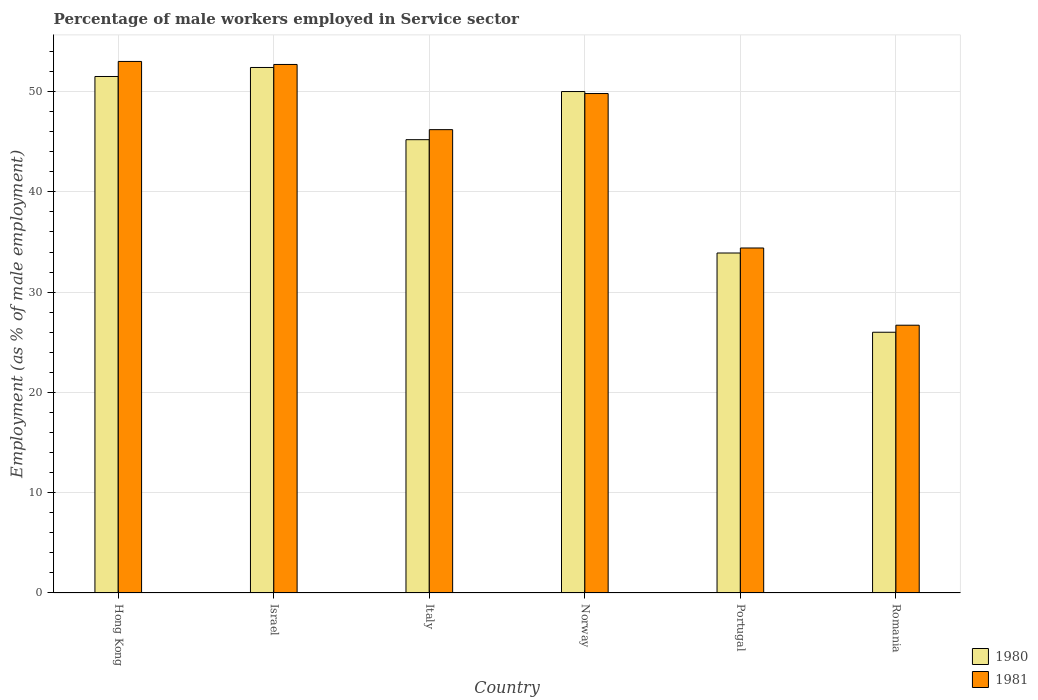How many different coloured bars are there?
Provide a short and direct response. 2. How many groups of bars are there?
Your response must be concise. 6. Are the number of bars per tick equal to the number of legend labels?
Ensure brevity in your answer.  Yes. How many bars are there on the 4th tick from the left?
Keep it short and to the point. 2. What is the label of the 1st group of bars from the left?
Your answer should be very brief. Hong Kong. Across all countries, what is the maximum percentage of male workers employed in Service sector in 1980?
Offer a very short reply. 52.4. Across all countries, what is the minimum percentage of male workers employed in Service sector in 1980?
Keep it short and to the point. 26. In which country was the percentage of male workers employed in Service sector in 1981 maximum?
Your answer should be compact. Hong Kong. In which country was the percentage of male workers employed in Service sector in 1980 minimum?
Keep it short and to the point. Romania. What is the total percentage of male workers employed in Service sector in 1980 in the graph?
Keep it short and to the point. 259. What is the difference between the percentage of male workers employed in Service sector in 1981 in Israel and that in Italy?
Keep it short and to the point. 6.5. What is the difference between the percentage of male workers employed in Service sector in 1981 in Hong Kong and the percentage of male workers employed in Service sector in 1980 in Italy?
Make the answer very short. 7.8. What is the average percentage of male workers employed in Service sector in 1980 per country?
Ensure brevity in your answer.  43.17. What is the difference between the percentage of male workers employed in Service sector of/in 1981 and percentage of male workers employed in Service sector of/in 1980 in Italy?
Make the answer very short. 1. In how many countries, is the percentage of male workers employed in Service sector in 1981 greater than 32 %?
Your answer should be compact. 5. What is the ratio of the percentage of male workers employed in Service sector in 1981 in Hong Kong to that in Portugal?
Provide a succinct answer. 1.54. Is the percentage of male workers employed in Service sector in 1981 in Norway less than that in Romania?
Your answer should be compact. No. Is the difference between the percentage of male workers employed in Service sector in 1981 in Norway and Portugal greater than the difference between the percentage of male workers employed in Service sector in 1980 in Norway and Portugal?
Give a very brief answer. No. What is the difference between the highest and the second highest percentage of male workers employed in Service sector in 1981?
Offer a terse response. -2.9. What is the difference between the highest and the lowest percentage of male workers employed in Service sector in 1980?
Your answer should be compact. 26.4. Is the sum of the percentage of male workers employed in Service sector in 1980 in Israel and Italy greater than the maximum percentage of male workers employed in Service sector in 1981 across all countries?
Offer a terse response. Yes. What does the 1st bar from the left in Norway represents?
Give a very brief answer. 1980. Are all the bars in the graph horizontal?
Your answer should be very brief. No. How many countries are there in the graph?
Offer a very short reply. 6. What is the difference between two consecutive major ticks on the Y-axis?
Make the answer very short. 10. Are the values on the major ticks of Y-axis written in scientific E-notation?
Give a very brief answer. No. Does the graph contain grids?
Make the answer very short. Yes. What is the title of the graph?
Provide a short and direct response. Percentage of male workers employed in Service sector. What is the label or title of the Y-axis?
Your answer should be very brief. Employment (as % of male employment). What is the Employment (as % of male employment) in 1980 in Hong Kong?
Keep it short and to the point. 51.5. What is the Employment (as % of male employment) of 1980 in Israel?
Provide a succinct answer. 52.4. What is the Employment (as % of male employment) in 1981 in Israel?
Keep it short and to the point. 52.7. What is the Employment (as % of male employment) of 1980 in Italy?
Offer a terse response. 45.2. What is the Employment (as % of male employment) of 1981 in Italy?
Offer a very short reply. 46.2. What is the Employment (as % of male employment) of 1981 in Norway?
Your answer should be compact. 49.8. What is the Employment (as % of male employment) in 1980 in Portugal?
Make the answer very short. 33.9. What is the Employment (as % of male employment) of 1981 in Portugal?
Your answer should be very brief. 34.4. What is the Employment (as % of male employment) of 1980 in Romania?
Offer a terse response. 26. What is the Employment (as % of male employment) of 1981 in Romania?
Ensure brevity in your answer.  26.7. Across all countries, what is the maximum Employment (as % of male employment) in 1980?
Offer a very short reply. 52.4. Across all countries, what is the minimum Employment (as % of male employment) in 1980?
Your answer should be compact. 26. Across all countries, what is the minimum Employment (as % of male employment) of 1981?
Provide a succinct answer. 26.7. What is the total Employment (as % of male employment) of 1980 in the graph?
Your response must be concise. 259. What is the total Employment (as % of male employment) in 1981 in the graph?
Ensure brevity in your answer.  262.8. What is the difference between the Employment (as % of male employment) in 1981 in Hong Kong and that in Israel?
Make the answer very short. 0.3. What is the difference between the Employment (as % of male employment) of 1981 in Hong Kong and that in Romania?
Make the answer very short. 26.3. What is the difference between the Employment (as % of male employment) in 1981 in Israel and that in Italy?
Your answer should be very brief. 6.5. What is the difference between the Employment (as % of male employment) in 1980 in Israel and that in Norway?
Offer a very short reply. 2.4. What is the difference between the Employment (as % of male employment) in 1981 in Israel and that in Norway?
Offer a terse response. 2.9. What is the difference between the Employment (as % of male employment) of 1980 in Israel and that in Portugal?
Offer a terse response. 18.5. What is the difference between the Employment (as % of male employment) of 1980 in Israel and that in Romania?
Keep it short and to the point. 26.4. What is the difference between the Employment (as % of male employment) in 1981 in Italy and that in Norway?
Offer a terse response. -3.6. What is the difference between the Employment (as % of male employment) of 1981 in Italy and that in Romania?
Give a very brief answer. 19.5. What is the difference between the Employment (as % of male employment) of 1980 in Norway and that in Portugal?
Make the answer very short. 16.1. What is the difference between the Employment (as % of male employment) of 1980 in Norway and that in Romania?
Offer a terse response. 24. What is the difference between the Employment (as % of male employment) in 1981 in Norway and that in Romania?
Provide a short and direct response. 23.1. What is the difference between the Employment (as % of male employment) in 1980 in Portugal and that in Romania?
Offer a very short reply. 7.9. What is the difference between the Employment (as % of male employment) of 1981 in Portugal and that in Romania?
Give a very brief answer. 7.7. What is the difference between the Employment (as % of male employment) in 1980 in Hong Kong and the Employment (as % of male employment) in 1981 in Norway?
Offer a terse response. 1.7. What is the difference between the Employment (as % of male employment) in 1980 in Hong Kong and the Employment (as % of male employment) in 1981 in Romania?
Your response must be concise. 24.8. What is the difference between the Employment (as % of male employment) in 1980 in Israel and the Employment (as % of male employment) in 1981 in Italy?
Ensure brevity in your answer.  6.2. What is the difference between the Employment (as % of male employment) in 1980 in Israel and the Employment (as % of male employment) in 1981 in Romania?
Your response must be concise. 25.7. What is the difference between the Employment (as % of male employment) of 1980 in Italy and the Employment (as % of male employment) of 1981 in Norway?
Your answer should be very brief. -4.6. What is the difference between the Employment (as % of male employment) in 1980 in Italy and the Employment (as % of male employment) in 1981 in Romania?
Keep it short and to the point. 18.5. What is the difference between the Employment (as % of male employment) of 1980 in Norway and the Employment (as % of male employment) of 1981 in Portugal?
Make the answer very short. 15.6. What is the difference between the Employment (as % of male employment) of 1980 in Norway and the Employment (as % of male employment) of 1981 in Romania?
Your answer should be very brief. 23.3. What is the difference between the Employment (as % of male employment) in 1980 in Portugal and the Employment (as % of male employment) in 1981 in Romania?
Give a very brief answer. 7.2. What is the average Employment (as % of male employment) in 1980 per country?
Your answer should be compact. 43.17. What is the average Employment (as % of male employment) of 1981 per country?
Offer a very short reply. 43.8. What is the difference between the Employment (as % of male employment) of 1980 and Employment (as % of male employment) of 1981 in Israel?
Provide a succinct answer. -0.3. What is the difference between the Employment (as % of male employment) in 1980 and Employment (as % of male employment) in 1981 in Norway?
Your answer should be compact. 0.2. What is the ratio of the Employment (as % of male employment) in 1980 in Hong Kong to that in Israel?
Your answer should be very brief. 0.98. What is the ratio of the Employment (as % of male employment) in 1981 in Hong Kong to that in Israel?
Offer a very short reply. 1.01. What is the ratio of the Employment (as % of male employment) of 1980 in Hong Kong to that in Italy?
Provide a short and direct response. 1.14. What is the ratio of the Employment (as % of male employment) of 1981 in Hong Kong to that in Italy?
Your response must be concise. 1.15. What is the ratio of the Employment (as % of male employment) in 1980 in Hong Kong to that in Norway?
Ensure brevity in your answer.  1.03. What is the ratio of the Employment (as % of male employment) in 1981 in Hong Kong to that in Norway?
Your answer should be very brief. 1.06. What is the ratio of the Employment (as % of male employment) in 1980 in Hong Kong to that in Portugal?
Keep it short and to the point. 1.52. What is the ratio of the Employment (as % of male employment) of 1981 in Hong Kong to that in Portugal?
Your answer should be compact. 1.54. What is the ratio of the Employment (as % of male employment) in 1980 in Hong Kong to that in Romania?
Keep it short and to the point. 1.98. What is the ratio of the Employment (as % of male employment) of 1981 in Hong Kong to that in Romania?
Keep it short and to the point. 1.99. What is the ratio of the Employment (as % of male employment) of 1980 in Israel to that in Italy?
Make the answer very short. 1.16. What is the ratio of the Employment (as % of male employment) in 1981 in Israel to that in Italy?
Keep it short and to the point. 1.14. What is the ratio of the Employment (as % of male employment) of 1980 in Israel to that in Norway?
Your answer should be compact. 1.05. What is the ratio of the Employment (as % of male employment) in 1981 in Israel to that in Norway?
Provide a short and direct response. 1.06. What is the ratio of the Employment (as % of male employment) of 1980 in Israel to that in Portugal?
Keep it short and to the point. 1.55. What is the ratio of the Employment (as % of male employment) of 1981 in Israel to that in Portugal?
Give a very brief answer. 1.53. What is the ratio of the Employment (as % of male employment) in 1980 in Israel to that in Romania?
Your answer should be compact. 2.02. What is the ratio of the Employment (as % of male employment) of 1981 in Israel to that in Romania?
Give a very brief answer. 1.97. What is the ratio of the Employment (as % of male employment) in 1980 in Italy to that in Norway?
Keep it short and to the point. 0.9. What is the ratio of the Employment (as % of male employment) of 1981 in Italy to that in Norway?
Keep it short and to the point. 0.93. What is the ratio of the Employment (as % of male employment) of 1980 in Italy to that in Portugal?
Keep it short and to the point. 1.33. What is the ratio of the Employment (as % of male employment) in 1981 in Italy to that in Portugal?
Your answer should be very brief. 1.34. What is the ratio of the Employment (as % of male employment) of 1980 in Italy to that in Romania?
Provide a short and direct response. 1.74. What is the ratio of the Employment (as % of male employment) in 1981 in Italy to that in Romania?
Give a very brief answer. 1.73. What is the ratio of the Employment (as % of male employment) in 1980 in Norway to that in Portugal?
Offer a terse response. 1.47. What is the ratio of the Employment (as % of male employment) of 1981 in Norway to that in Portugal?
Provide a short and direct response. 1.45. What is the ratio of the Employment (as % of male employment) of 1980 in Norway to that in Romania?
Give a very brief answer. 1.92. What is the ratio of the Employment (as % of male employment) in 1981 in Norway to that in Romania?
Your response must be concise. 1.87. What is the ratio of the Employment (as % of male employment) in 1980 in Portugal to that in Romania?
Your answer should be very brief. 1.3. What is the ratio of the Employment (as % of male employment) in 1981 in Portugal to that in Romania?
Your answer should be compact. 1.29. What is the difference between the highest and the second highest Employment (as % of male employment) in 1980?
Your response must be concise. 0.9. What is the difference between the highest and the second highest Employment (as % of male employment) in 1981?
Give a very brief answer. 0.3. What is the difference between the highest and the lowest Employment (as % of male employment) in 1980?
Offer a very short reply. 26.4. What is the difference between the highest and the lowest Employment (as % of male employment) in 1981?
Make the answer very short. 26.3. 